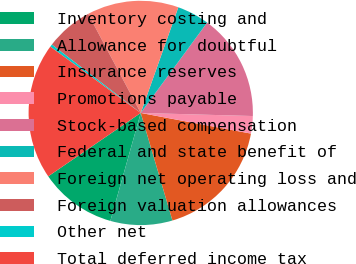<chart> <loc_0><loc_0><loc_500><loc_500><pie_chart><fcel>Inventory costing and<fcel>Allowance for doubtful<fcel>Insurance reserves<fcel>Promotions payable<fcel>Stock-based compensation<fcel>Federal and state benefit of<fcel>Foreign net operating loss and<fcel>Foreign valuation allowances<fcel>Other net<fcel>Total deferred income tax<nl><fcel>11.07%<fcel>8.93%<fcel>17.49%<fcel>2.51%<fcel>15.35%<fcel>4.65%<fcel>13.21%<fcel>6.79%<fcel>0.37%<fcel>19.63%<nl></chart> 